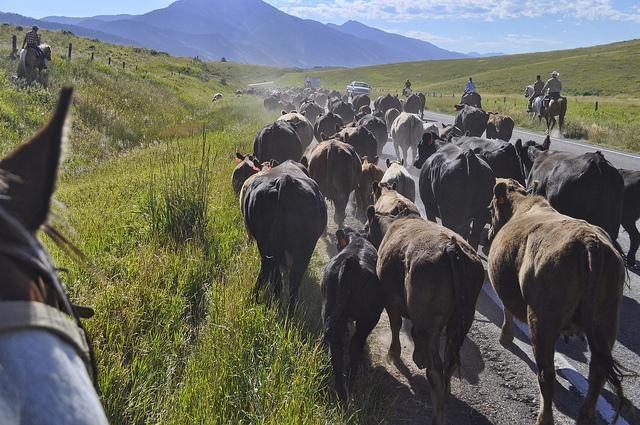What tragedy can happen here?
Answer the question by selecting the correct answer among the 4 following choices.
Options: Earthquake, fire, cows hit, volcano eruption. Cows hit. 